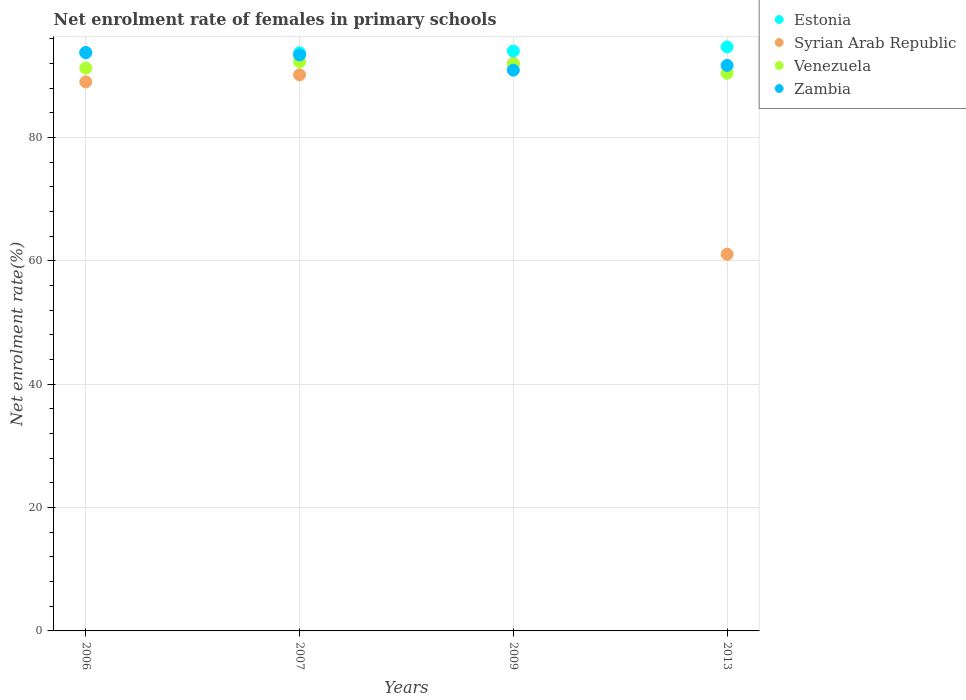What is the net enrolment rate of females in primary schools in Venezuela in 2013?
Provide a succinct answer. 90.42. Across all years, what is the maximum net enrolment rate of females in primary schools in Estonia?
Make the answer very short. 94.68. Across all years, what is the minimum net enrolment rate of females in primary schools in Venezuela?
Your answer should be compact. 90.42. In which year was the net enrolment rate of females in primary schools in Syrian Arab Republic maximum?
Offer a very short reply. 2009. In which year was the net enrolment rate of females in primary schools in Zambia minimum?
Keep it short and to the point. 2009. What is the total net enrolment rate of females in primary schools in Venezuela in the graph?
Make the answer very short. 365.84. What is the difference between the net enrolment rate of females in primary schools in Zambia in 2009 and that in 2013?
Your answer should be very brief. -0.77. What is the difference between the net enrolment rate of females in primary schools in Syrian Arab Republic in 2006 and the net enrolment rate of females in primary schools in Venezuela in 2013?
Your answer should be very brief. -1.4. What is the average net enrolment rate of females in primary schools in Zambia per year?
Your response must be concise. 92.44. In the year 2006, what is the difference between the net enrolment rate of females in primary schools in Estonia and net enrolment rate of females in primary schools in Venezuela?
Provide a short and direct response. 2.51. In how many years, is the net enrolment rate of females in primary schools in Estonia greater than 72 %?
Make the answer very short. 4. What is the ratio of the net enrolment rate of females in primary schools in Zambia in 2006 to that in 2009?
Your answer should be compact. 1.03. What is the difference between the highest and the second highest net enrolment rate of females in primary schools in Venezuela?
Provide a succinct answer. 0.35. What is the difference between the highest and the lowest net enrolment rate of females in primary schools in Syrian Arab Republic?
Your response must be concise. 30.92. In how many years, is the net enrolment rate of females in primary schools in Zambia greater than the average net enrolment rate of females in primary schools in Zambia taken over all years?
Your response must be concise. 2. Is it the case that in every year, the sum of the net enrolment rate of females in primary schools in Zambia and net enrolment rate of females in primary schools in Estonia  is greater than the sum of net enrolment rate of females in primary schools in Venezuela and net enrolment rate of females in primary schools in Syrian Arab Republic?
Offer a very short reply. Yes. Does the net enrolment rate of females in primary schools in Syrian Arab Republic monotonically increase over the years?
Offer a very short reply. No. Is the net enrolment rate of females in primary schools in Estonia strictly less than the net enrolment rate of females in primary schools in Zambia over the years?
Keep it short and to the point. No. How many years are there in the graph?
Offer a terse response. 4. Are the values on the major ticks of Y-axis written in scientific E-notation?
Ensure brevity in your answer.  No. Does the graph contain grids?
Your response must be concise. Yes. Where does the legend appear in the graph?
Provide a short and direct response. Top right. How many legend labels are there?
Give a very brief answer. 4. What is the title of the graph?
Give a very brief answer. Net enrolment rate of females in primary schools. What is the label or title of the Y-axis?
Your answer should be compact. Net enrolment rate(%). What is the Net enrolment rate(%) in Estonia in 2006?
Provide a short and direct response. 93.76. What is the Net enrolment rate(%) in Syrian Arab Republic in 2006?
Provide a short and direct response. 89.02. What is the Net enrolment rate(%) in Venezuela in 2006?
Offer a terse response. 91.25. What is the Net enrolment rate(%) in Zambia in 2006?
Offer a very short reply. 93.77. What is the Net enrolment rate(%) in Estonia in 2007?
Your answer should be compact. 93.73. What is the Net enrolment rate(%) in Syrian Arab Republic in 2007?
Make the answer very short. 90.16. What is the Net enrolment rate(%) in Venezuela in 2007?
Provide a short and direct response. 92.26. What is the Net enrolment rate(%) of Zambia in 2007?
Your answer should be compact. 93.38. What is the Net enrolment rate(%) in Estonia in 2009?
Provide a short and direct response. 94.01. What is the Net enrolment rate(%) in Syrian Arab Republic in 2009?
Make the answer very short. 92. What is the Net enrolment rate(%) in Venezuela in 2009?
Make the answer very short. 91.91. What is the Net enrolment rate(%) in Zambia in 2009?
Provide a succinct answer. 90.91. What is the Net enrolment rate(%) in Estonia in 2013?
Your answer should be compact. 94.68. What is the Net enrolment rate(%) in Syrian Arab Republic in 2013?
Make the answer very short. 61.07. What is the Net enrolment rate(%) of Venezuela in 2013?
Your answer should be very brief. 90.42. What is the Net enrolment rate(%) in Zambia in 2013?
Your response must be concise. 91.69. Across all years, what is the maximum Net enrolment rate(%) of Estonia?
Provide a short and direct response. 94.68. Across all years, what is the maximum Net enrolment rate(%) in Syrian Arab Republic?
Offer a very short reply. 92. Across all years, what is the maximum Net enrolment rate(%) in Venezuela?
Give a very brief answer. 92.26. Across all years, what is the maximum Net enrolment rate(%) of Zambia?
Ensure brevity in your answer.  93.77. Across all years, what is the minimum Net enrolment rate(%) in Estonia?
Your answer should be very brief. 93.73. Across all years, what is the minimum Net enrolment rate(%) in Syrian Arab Republic?
Your answer should be very brief. 61.07. Across all years, what is the minimum Net enrolment rate(%) of Venezuela?
Give a very brief answer. 90.42. Across all years, what is the minimum Net enrolment rate(%) of Zambia?
Provide a succinct answer. 90.91. What is the total Net enrolment rate(%) in Estonia in the graph?
Provide a short and direct response. 376.18. What is the total Net enrolment rate(%) in Syrian Arab Republic in the graph?
Your response must be concise. 332.24. What is the total Net enrolment rate(%) of Venezuela in the graph?
Ensure brevity in your answer.  365.84. What is the total Net enrolment rate(%) in Zambia in the graph?
Your response must be concise. 369.75. What is the difference between the Net enrolment rate(%) of Estonia in 2006 and that in 2007?
Offer a terse response. 0.03. What is the difference between the Net enrolment rate(%) of Syrian Arab Republic in 2006 and that in 2007?
Provide a short and direct response. -1.15. What is the difference between the Net enrolment rate(%) of Venezuela in 2006 and that in 2007?
Give a very brief answer. -1.01. What is the difference between the Net enrolment rate(%) in Zambia in 2006 and that in 2007?
Provide a short and direct response. 0.39. What is the difference between the Net enrolment rate(%) in Estonia in 2006 and that in 2009?
Offer a terse response. -0.25. What is the difference between the Net enrolment rate(%) of Syrian Arab Republic in 2006 and that in 2009?
Your response must be concise. -2.98. What is the difference between the Net enrolment rate(%) in Venezuela in 2006 and that in 2009?
Your response must be concise. -0.66. What is the difference between the Net enrolment rate(%) of Zambia in 2006 and that in 2009?
Provide a succinct answer. 2.86. What is the difference between the Net enrolment rate(%) of Estonia in 2006 and that in 2013?
Provide a succinct answer. -0.92. What is the difference between the Net enrolment rate(%) in Syrian Arab Republic in 2006 and that in 2013?
Your answer should be very brief. 27.95. What is the difference between the Net enrolment rate(%) in Venezuela in 2006 and that in 2013?
Provide a succinct answer. 0.83. What is the difference between the Net enrolment rate(%) in Zambia in 2006 and that in 2013?
Your answer should be very brief. 2.08. What is the difference between the Net enrolment rate(%) of Estonia in 2007 and that in 2009?
Provide a succinct answer. -0.28. What is the difference between the Net enrolment rate(%) in Syrian Arab Republic in 2007 and that in 2009?
Give a very brief answer. -1.83. What is the difference between the Net enrolment rate(%) of Venezuela in 2007 and that in 2009?
Provide a short and direct response. 0.35. What is the difference between the Net enrolment rate(%) of Zambia in 2007 and that in 2009?
Offer a terse response. 2.47. What is the difference between the Net enrolment rate(%) of Estonia in 2007 and that in 2013?
Your answer should be compact. -0.95. What is the difference between the Net enrolment rate(%) of Syrian Arab Republic in 2007 and that in 2013?
Your answer should be compact. 29.09. What is the difference between the Net enrolment rate(%) of Venezuela in 2007 and that in 2013?
Your response must be concise. 1.84. What is the difference between the Net enrolment rate(%) in Zambia in 2007 and that in 2013?
Provide a succinct answer. 1.69. What is the difference between the Net enrolment rate(%) in Estonia in 2009 and that in 2013?
Your response must be concise. -0.67. What is the difference between the Net enrolment rate(%) of Syrian Arab Republic in 2009 and that in 2013?
Your answer should be compact. 30.92. What is the difference between the Net enrolment rate(%) of Venezuela in 2009 and that in 2013?
Give a very brief answer. 1.49. What is the difference between the Net enrolment rate(%) in Zambia in 2009 and that in 2013?
Offer a very short reply. -0.77. What is the difference between the Net enrolment rate(%) in Estonia in 2006 and the Net enrolment rate(%) in Syrian Arab Republic in 2007?
Offer a terse response. 3.6. What is the difference between the Net enrolment rate(%) of Estonia in 2006 and the Net enrolment rate(%) of Venezuela in 2007?
Keep it short and to the point. 1.5. What is the difference between the Net enrolment rate(%) of Estonia in 2006 and the Net enrolment rate(%) of Zambia in 2007?
Your answer should be compact. 0.38. What is the difference between the Net enrolment rate(%) in Syrian Arab Republic in 2006 and the Net enrolment rate(%) in Venezuela in 2007?
Keep it short and to the point. -3.25. What is the difference between the Net enrolment rate(%) of Syrian Arab Republic in 2006 and the Net enrolment rate(%) of Zambia in 2007?
Your answer should be very brief. -4.36. What is the difference between the Net enrolment rate(%) of Venezuela in 2006 and the Net enrolment rate(%) of Zambia in 2007?
Offer a terse response. -2.13. What is the difference between the Net enrolment rate(%) of Estonia in 2006 and the Net enrolment rate(%) of Syrian Arab Republic in 2009?
Make the answer very short. 1.76. What is the difference between the Net enrolment rate(%) in Estonia in 2006 and the Net enrolment rate(%) in Venezuela in 2009?
Offer a very short reply. 1.85. What is the difference between the Net enrolment rate(%) of Estonia in 2006 and the Net enrolment rate(%) of Zambia in 2009?
Provide a succinct answer. 2.85. What is the difference between the Net enrolment rate(%) in Syrian Arab Republic in 2006 and the Net enrolment rate(%) in Venezuela in 2009?
Offer a very short reply. -2.89. What is the difference between the Net enrolment rate(%) of Syrian Arab Republic in 2006 and the Net enrolment rate(%) of Zambia in 2009?
Your answer should be very brief. -1.9. What is the difference between the Net enrolment rate(%) of Venezuela in 2006 and the Net enrolment rate(%) of Zambia in 2009?
Your answer should be very brief. 0.34. What is the difference between the Net enrolment rate(%) of Estonia in 2006 and the Net enrolment rate(%) of Syrian Arab Republic in 2013?
Offer a terse response. 32.69. What is the difference between the Net enrolment rate(%) of Estonia in 2006 and the Net enrolment rate(%) of Venezuela in 2013?
Make the answer very short. 3.34. What is the difference between the Net enrolment rate(%) of Estonia in 2006 and the Net enrolment rate(%) of Zambia in 2013?
Ensure brevity in your answer.  2.07. What is the difference between the Net enrolment rate(%) in Syrian Arab Republic in 2006 and the Net enrolment rate(%) in Venezuela in 2013?
Your answer should be very brief. -1.4. What is the difference between the Net enrolment rate(%) of Syrian Arab Republic in 2006 and the Net enrolment rate(%) of Zambia in 2013?
Offer a terse response. -2.67. What is the difference between the Net enrolment rate(%) of Venezuela in 2006 and the Net enrolment rate(%) of Zambia in 2013?
Your answer should be compact. -0.44. What is the difference between the Net enrolment rate(%) of Estonia in 2007 and the Net enrolment rate(%) of Syrian Arab Republic in 2009?
Keep it short and to the point. 1.73. What is the difference between the Net enrolment rate(%) of Estonia in 2007 and the Net enrolment rate(%) of Venezuela in 2009?
Offer a terse response. 1.82. What is the difference between the Net enrolment rate(%) in Estonia in 2007 and the Net enrolment rate(%) in Zambia in 2009?
Offer a very short reply. 2.81. What is the difference between the Net enrolment rate(%) of Syrian Arab Republic in 2007 and the Net enrolment rate(%) of Venezuela in 2009?
Provide a succinct answer. -1.75. What is the difference between the Net enrolment rate(%) in Syrian Arab Republic in 2007 and the Net enrolment rate(%) in Zambia in 2009?
Ensure brevity in your answer.  -0.75. What is the difference between the Net enrolment rate(%) in Venezuela in 2007 and the Net enrolment rate(%) in Zambia in 2009?
Give a very brief answer. 1.35. What is the difference between the Net enrolment rate(%) of Estonia in 2007 and the Net enrolment rate(%) of Syrian Arab Republic in 2013?
Your answer should be very brief. 32.66. What is the difference between the Net enrolment rate(%) of Estonia in 2007 and the Net enrolment rate(%) of Venezuela in 2013?
Offer a very short reply. 3.31. What is the difference between the Net enrolment rate(%) in Estonia in 2007 and the Net enrolment rate(%) in Zambia in 2013?
Offer a terse response. 2.04. What is the difference between the Net enrolment rate(%) in Syrian Arab Republic in 2007 and the Net enrolment rate(%) in Venezuela in 2013?
Your answer should be very brief. -0.26. What is the difference between the Net enrolment rate(%) of Syrian Arab Republic in 2007 and the Net enrolment rate(%) of Zambia in 2013?
Give a very brief answer. -1.53. What is the difference between the Net enrolment rate(%) of Venezuela in 2007 and the Net enrolment rate(%) of Zambia in 2013?
Make the answer very short. 0.57. What is the difference between the Net enrolment rate(%) of Estonia in 2009 and the Net enrolment rate(%) of Syrian Arab Republic in 2013?
Make the answer very short. 32.94. What is the difference between the Net enrolment rate(%) of Estonia in 2009 and the Net enrolment rate(%) of Venezuela in 2013?
Offer a very short reply. 3.59. What is the difference between the Net enrolment rate(%) in Estonia in 2009 and the Net enrolment rate(%) in Zambia in 2013?
Your answer should be compact. 2.32. What is the difference between the Net enrolment rate(%) of Syrian Arab Republic in 2009 and the Net enrolment rate(%) of Venezuela in 2013?
Provide a succinct answer. 1.58. What is the difference between the Net enrolment rate(%) of Syrian Arab Republic in 2009 and the Net enrolment rate(%) of Zambia in 2013?
Give a very brief answer. 0.31. What is the difference between the Net enrolment rate(%) in Venezuela in 2009 and the Net enrolment rate(%) in Zambia in 2013?
Provide a short and direct response. 0.22. What is the average Net enrolment rate(%) of Estonia per year?
Provide a succinct answer. 94.04. What is the average Net enrolment rate(%) of Syrian Arab Republic per year?
Offer a very short reply. 83.06. What is the average Net enrolment rate(%) in Venezuela per year?
Offer a terse response. 91.46. What is the average Net enrolment rate(%) in Zambia per year?
Keep it short and to the point. 92.44. In the year 2006, what is the difference between the Net enrolment rate(%) in Estonia and Net enrolment rate(%) in Syrian Arab Republic?
Provide a succinct answer. 4.74. In the year 2006, what is the difference between the Net enrolment rate(%) in Estonia and Net enrolment rate(%) in Venezuela?
Your answer should be compact. 2.51. In the year 2006, what is the difference between the Net enrolment rate(%) in Estonia and Net enrolment rate(%) in Zambia?
Your answer should be very brief. -0.01. In the year 2006, what is the difference between the Net enrolment rate(%) of Syrian Arab Republic and Net enrolment rate(%) of Venezuela?
Offer a very short reply. -2.24. In the year 2006, what is the difference between the Net enrolment rate(%) in Syrian Arab Republic and Net enrolment rate(%) in Zambia?
Offer a very short reply. -4.75. In the year 2006, what is the difference between the Net enrolment rate(%) in Venezuela and Net enrolment rate(%) in Zambia?
Offer a very short reply. -2.52. In the year 2007, what is the difference between the Net enrolment rate(%) in Estonia and Net enrolment rate(%) in Syrian Arab Republic?
Provide a short and direct response. 3.57. In the year 2007, what is the difference between the Net enrolment rate(%) in Estonia and Net enrolment rate(%) in Venezuela?
Your response must be concise. 1.47. In the year 2007, what is the difference between the Net enrolment rate(%) in Estonia and Net enrolment rate(%) in Zambia?
Give a very brief answer. 0.35. In the year 2007, what is the difference between the Net enrolment rate(%) of Syrian Arab Republic and Net enrolment rate(%) of Venezuela?
Provide a succinct answer. -2.1. In the year 2007, what is the difference between the Net enrolment rate(%) of Syrian Arab Republic and Net enrolment rate(%) of Zambia?
Provide a succinct answer. -3.22. In the year 2007, what is the difference between the Net enrolment rate(%) of Venezuela and Net enrolment rate(%) of Zambia?
Make the answer very short. -1.12. In the year 2009, what is the difference between the Net enrolment rate(%) in Estonia and Net enrolment rate(%) in Syrian Arab Republic?
Offer a very short reply. 2.01. In the year 2009, what is the difference between the Net enrolment rate(%) in Estonia and Net enrolment rate(%) in Venezuela?
Your answer should be very brief. 2.1. In the year 2009, what is the difference between the Net enrolment rate(%) in Estonia and Net enrolment rate(%) in Zambia?
Offer a terse response. 3.09. In the year 2009, what is the difference between the Net enrolment rate(%) of Syrian Arab Republic and Net enrolment rate(%) of Venezuela?
Offer a very short reply. 0.09. In the year 2009, what is the difference between the Net enrolment rate(%) in Syrian Arab Republic and Net enrolment rate(%) in Zambia?
Your response must be concise. 1.08. In the year 2009, what is the difference between the Net enrolment rate(%) of Venezuela and Net enrolment rate(%) of Zambia?
Your answer should be very brief. 0.99. In the year 2013, what is the difference between the Net enrolment rate(%) in Estonia and Net enrolment rate(%) in Syrian Arab Republic?
Provide a succinct answer. 33.61. In the year 2013, what is the difference between the Net enrolment rate(%) of Estonia and Net enrolment rate(%) of Venezuela?
Your response must be concise. 4.26. In the year 2013, what is the difference between the Net enrolment rate(%) in Estonia and Net enrolment rate(%) in Zambia?
Your response must be concise. 2.99. In the year 2013, what is the difference between the Net enrolment rate(%) of Syrian Arab Republic and Net enrolment rate(%) of Venezuela?
Provide a short and direct response. -29.35. In the year 2013, what is the difference between the Net enrolment rate(%) of Syrian Arab Republic and Net enrolment rate(%) of Zambia?
Offer a terse response. -30.62. In the year 2013, what is the difference between the Net enrolment rate(%) of Venezuela and Net enrolment rate(%) of Zambia?
Your response must be concise. -1.27. What is the ratio of the Net enrolment rate(%) of Estonia in 2006 to that in 2007?
Keep it short and to the point. 1. What is the ratio of the Net enrolment rate(%) of Syrian Arab Republic in 2006 to that in 2007?
Your answer should be compact. 0.99. What is the ratio of the Net enrolment rate(%) in Syrian Arab Republic in 2006 to that in 2009?
Provide a short and direct response. 0.97. What is the ratio of the Net enrolment rate(%) in Venezuela in 2006 to that in 2009?
Keep it short and to the point. 0.99. What is the ratio of the Net enrolment rate(%) in Zambia in 2006 to that in 2009?
Provide a succinct answer. 1.03. What is the ratio of the Net enrolment rate(%) of Estonia in 2006 to that in 2013?
Provide a succinct answer. 0.99. What is the ratio of the Net enrolment rate(%) in Syrian Arab Republic in 2006 to that in 2013?
Ensure brevity in your answer.  1.46. What is the ratio of the Net enrolment rate(%) in Venezuela in 2006 to that in 2013?
Offer a very short reply. 1.01. What is the ratio of the Net enrolment rate(%) of Zambia in 2006 to that in 2013?
Keep it short and to the point. 1.02. What is the ratio of the Net enrolment rate(%) in Estonia in 2007 to that in 2009?
Provide a short and direct response. 1. What is the ratio of the Net enrolment rate(%) in Syrian Arab Republic in 2007 to that in 2009?
Your response must be concise. 0.98. What is the ratio of the Net enrolment rate(%) in Venezuela in 2007 to that in 2009?
Give a very brief answer. 1. What is the ratio of the Net enrolment rate(%) of Zambia in 2007 to that in 2009?
Give a very brief answer. 1.03. What is the ratio of the Net enrolment rate(%) in Syrian Arab Republic in 2007 to that in 2013?
Your answer should be compact. 1.48. What is the ratio of the Net enrolment rate(%) in Venezuela in 2007 to that in 2013?
Provide a short and direct response. 1.02. What is the ratio of the Net enrolment rate(%) in Zambia in 2007 to that in 2013?
Your answer should be compact. 1.02. What is the ratio of the Net enrolment rate(%) in Estonia in 2009 to that in 2013?
Your response must be concise. 0.99. What is the ratio of the Net enrolment rate(%) of Syrian Arab Republic in 2009 to that in 2013?
Ensure brevity in your answer.  1.51. What is the ratio of the Net enrolment rate(%) of Venezuela in 2009 to that in 2013?
Make the answer very short. 1.02. What is the ratio of the Net enrolment rate(%) in Zambia in 2009 to that in 2013?
Provide a short and direct response. 0.99. What is the difference between the highest and the second highest Net enrolment rate(%) in Estonia?
Ensure brevity in your answer.  0.67. What is the difference between the highest and the second highest Net enrolment rate(%) in Syrian Arab Republic?
Offer a very short reply. 1.83. What is the difference between the highest and the second highest Net enrolment rate(%) in Venezuela?
Your answer should be very brief. 0.35. What is the difference between the highest and the second highest Net enrolment rate(%) of Zambia?
Offer a very short reply. 0.39. What is the difference between the highest and the lowest Net enrolment rate(%) in Estonia?
Provide a succinct answer. 0.95. What is the difference between the highest and the lowest Net enrolment rate(%) of Syrian Arab Republic?
Give a very brief answer. 30.92. What is the difference between the highest and the lowest Net enrolment rate(%) in Venezuela?
Ensure brevity in your answer.  1.84. What is the difference between the highest and the lowest Net enrolment rate(%) in Zambia?
Your answer should be very brief. 2.86. 